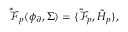<formula> <loc_0><loc_0><loc_500><loc_500>\dot { \bar { \mathcal { F } } } _ { p } ( \phi _ { \partial } , \Sigma ) = \{ \bar { \mathcal { F } } _ { p } , \bar { H } _ { p } \} ,</formula> 